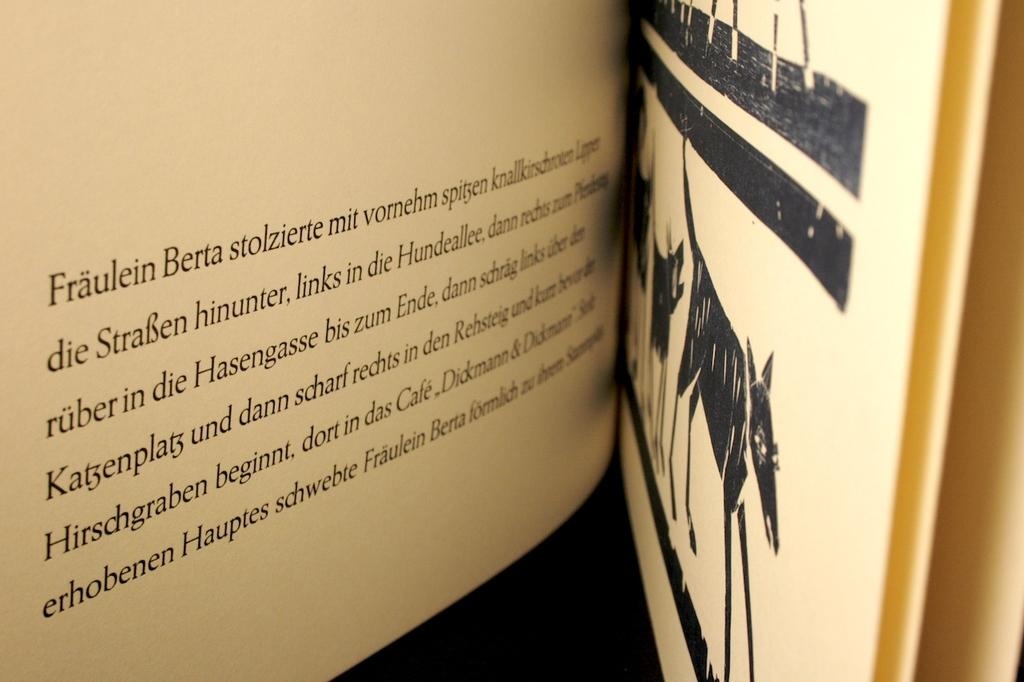<image>
Describe the image concisely. The text beginning with "Fraulein Berta" on the left and an illustration of a cow on the right side of the page. 